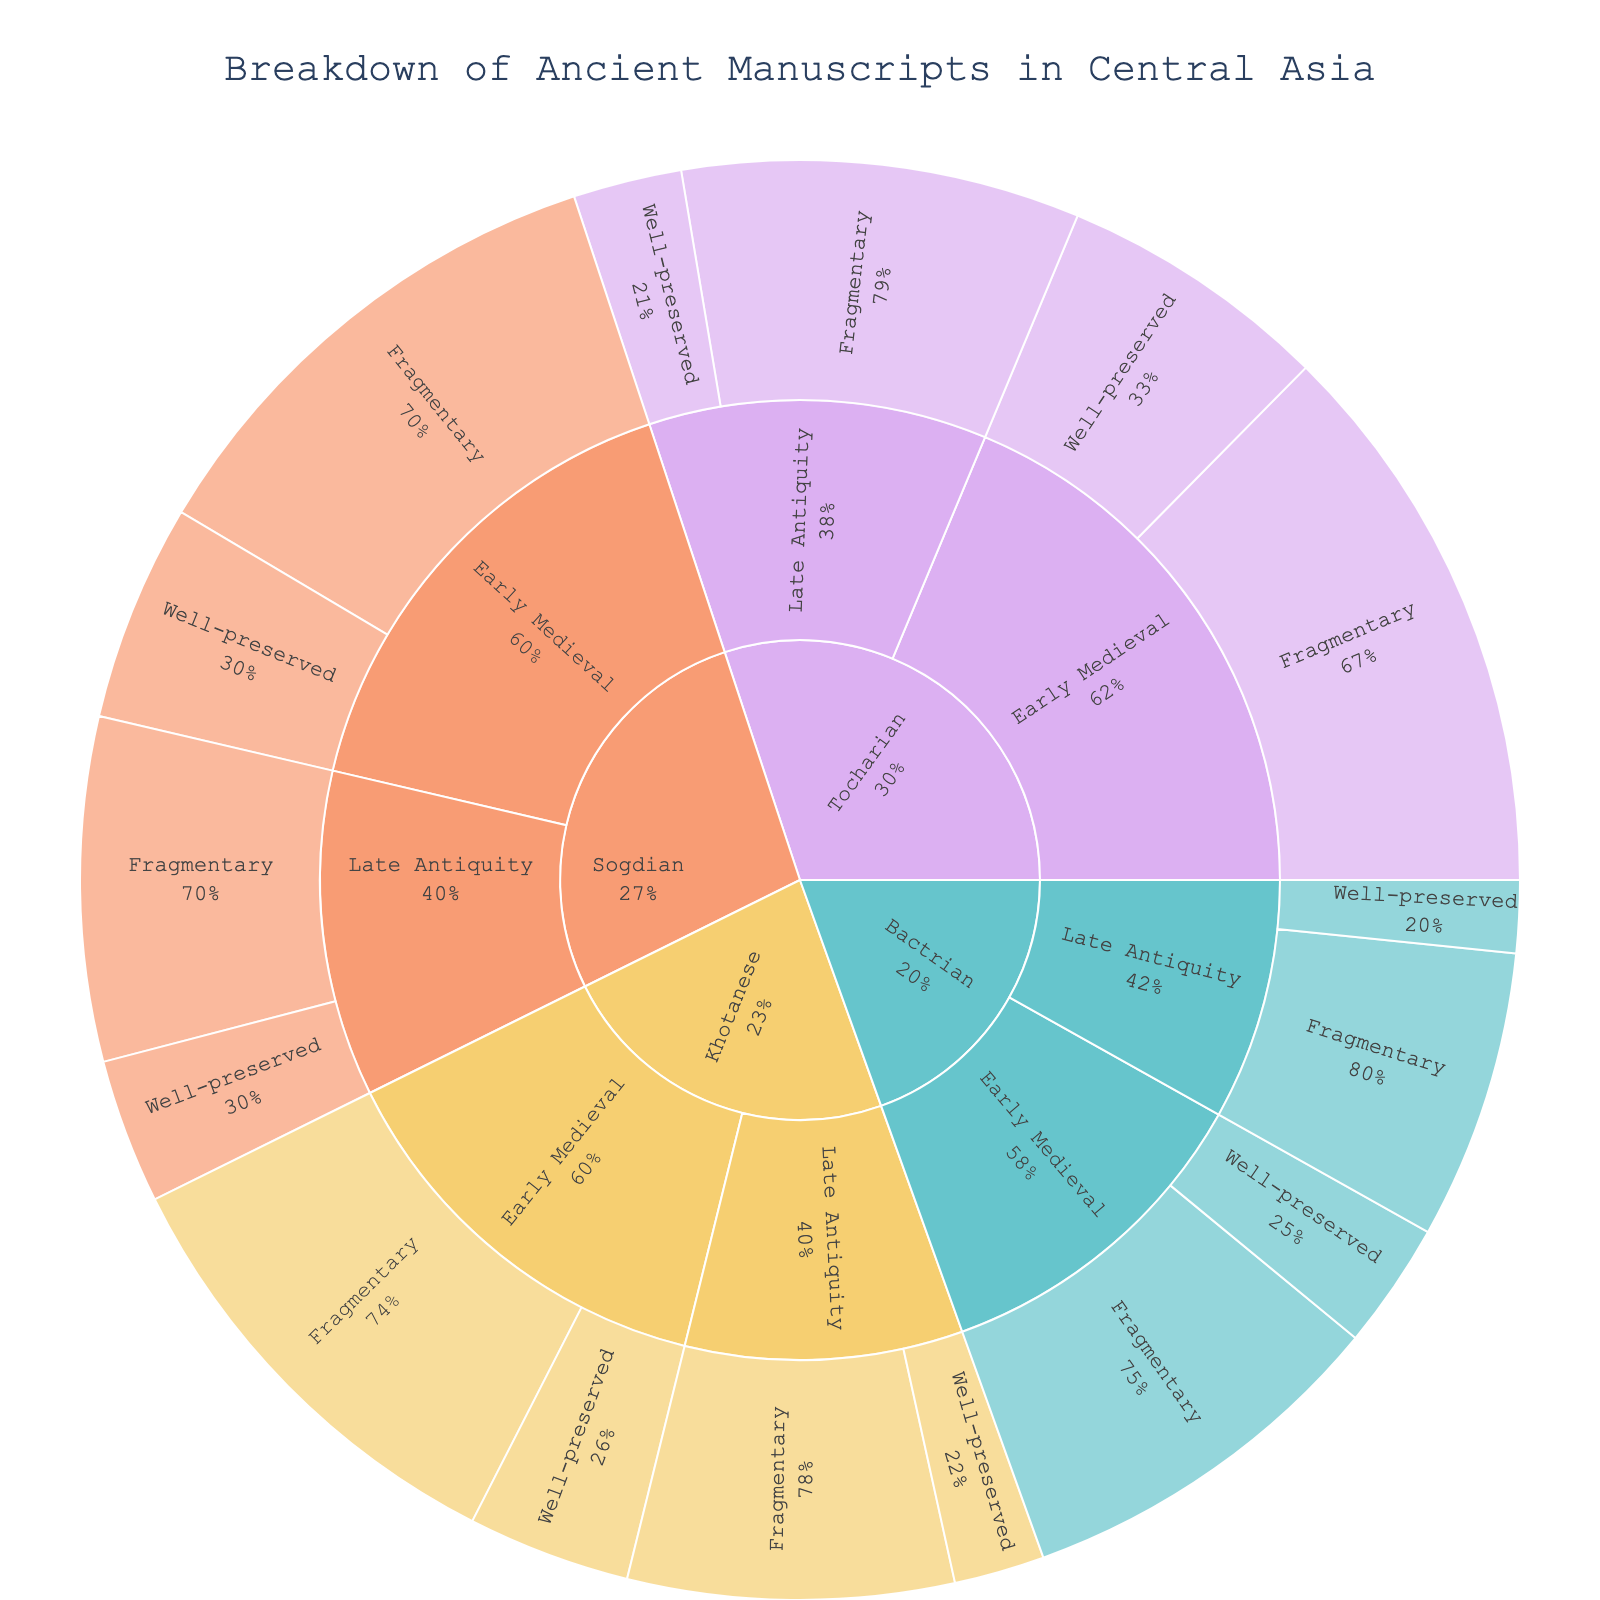what is the title of the figure? The title of the figure is usually displayed at the top of the plot and succinctly describes what the plot represents.
Answer: Breakdown of Ancient Manuscripts in Central Asia Which language has the highest number of well-preserved manuscripts from Early Medieval? To find this, look at the segments representing each language within the Early Medieval era and compare the 'Well-preserved' counts.
Answer: Tocharian Among the languages, which has the least number of manuscripts from the Late Antiquity era in total? Sum the 'Well-preserved' and 'Fragmentary' counts for each language in the Late Antiquity era and compare them. Khotanese has the least with 5 (well-preserved) + 18 (fragmentary) = 23 manuscripts.
Answer: Khotanese What era has the highest number of fragmentary manuscripts across all languages? Sum the fragmentary manuscripts of each language within each era. Early Medieval has the most fragmentary manuscripts.
Answer: Early Medieval What percentage of Sogdian manuscripts from the Late Antiquity era are well-preserved? The percentage is calculated as the number of well-preserved Sogdian manuscripts from Late Antiquity divided by the total number of Sogdian manuscripts from Late Antiquity: \( \frac{8}{8+19} \approx 29.6\% \).
Answer: 29.6% Which has a higher number of total manuscripts, Tocharian in the Early Medieval era or Sogdian in both eras combined? Add the well-preserved and fragmentary manuscripts for each grouping and compare. Tocharian in Early Medieval: \( 15 + 31 = 46 \), Sogdian total: \( 12 + 28 + 8 + 19 = 67 \).
Answer: Sogdian in both eras combined What is the total number of Khotanese manuscripts across both eras? Sum all the 'Well-preserved' and 'Fragmentary' manuscripts for Khotanese across both eras: \( 9 + 25 + 5 + 18 = 57 \).
Answer: 57 Which language has the smallest proportion of fragmentary manuscripts in the Early Medieval era? The proportion of fragmentary manuscripts for each language in Early Medieval can be found by dividing the fragmentary manuscripts by the total manuscripts for that language in that era. Sogdian: \( \frac{28}{12+28} = 70\% \), Tocharian: \( \frac{31}{15+31} = 67.4\% \), Khotanese: \( \frac{25}{9+25} = 73.5\% \), Bactrian: \( \frac{21}{7+21} = 75\% \).
Answer: Tocharian 